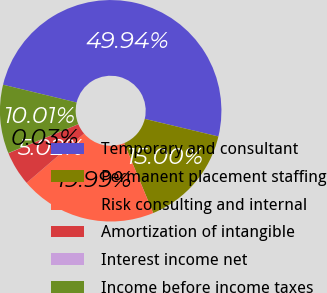<chart> <loc_0><loc_0><loc_500><loc_500><pie_chart><fcel>Temporary and consultant<fcel>Permanent placement staffing<fcel>Risk consulting and internal<fcel>Amortization of intangible<fcel>Interest income net<fcel>Income before income taxes<nl><fcel>49.94%<fcel>15.0%<fcel>19.99%<fcel>5.02%<fcel>0.03%<fcel>10.01%<nl></chart> 